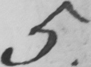What is written in this line of handwriting? 5 . 